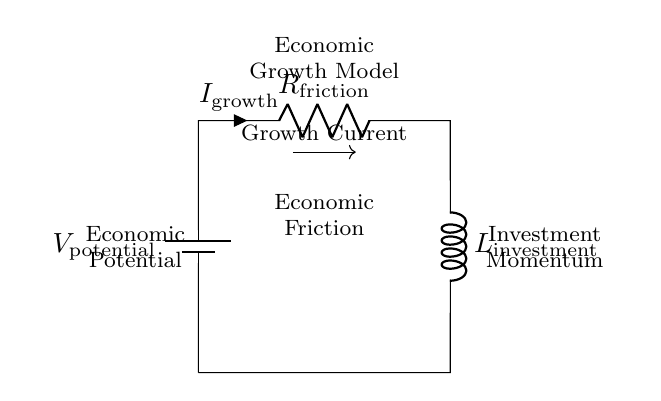What component represents economic friction in the circuit? The circuit diagram includes a resistor labeled as "R_friction" which represents economic friction, indicating factors that slow down economic growth.
Answer: R_friction What does the inductor represent in this circuit? The inductor in the circuit, labeled "L_investment," represents investment momentum, allowing for the simulation of delayed economic responses to investment changes.
Answer: L_investment What is the direction of the growth current in the circuit? The growth current flows from the battery through the resistor and then through the inductor back to the battery, as indicated by the arrow on the current label "I_growth."
Answer: From battery through resistor to inductor What would happen to the growth current if economic friction increases? Increasing economic friction (increasing resistance) would decrease the growth current by reducing the flow of economic activity, as the resistor impedes current flow.
Answer: Decrease How are the components connected in this circuit? The components are connected in a loop where the battery supplies voltage to the resistor first, then to the inductor, completing the circuit back to the battery.
Answer: In series What does the voltage source represent in terms of economic modeling? The voltage source, labeled "V_potential," represents the economic potential driving growth, indicating the overall economic capability or resources available for growth.
Answer: Economic potential What would an increase in investment momentum lead to in this model? An increase in investment momentum (inductance) would lead to a delayed increase in economic growth current as investments take time to influence the economy positively.
Answer: Increased growth current over time 